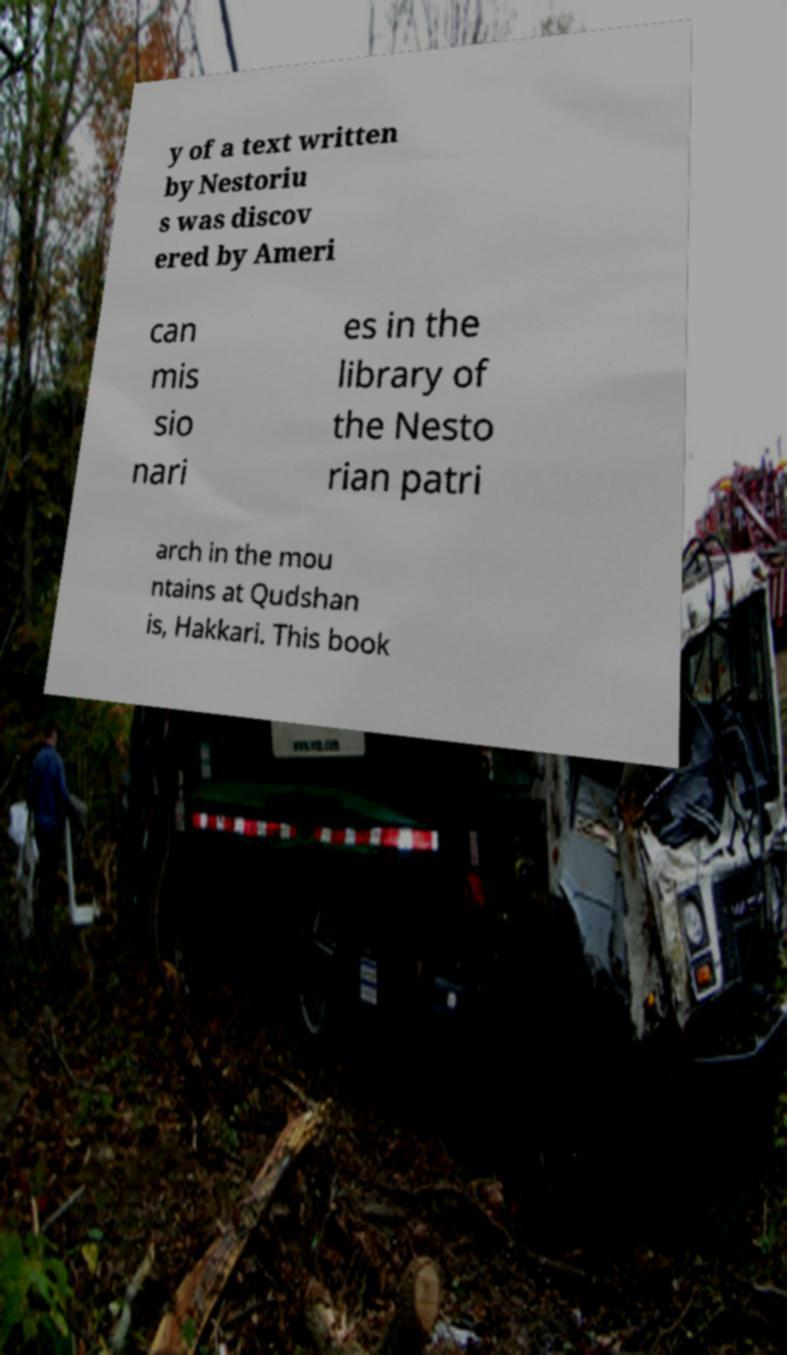There's text embedded in this image that I need extracted. Can you transcribe it verbatim? y of a text written by Nestoriu s was discov ered by Ameri can mis sio nari es in the library of the Nesto rian patri arch in the mou ntains at Qudshan is, Hakkari. This book 